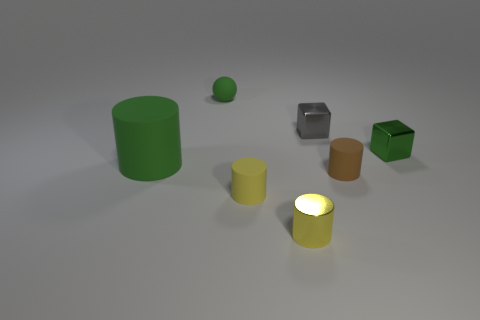What shapes are present in this image? The image features a variety of geometric shapes, including two cylinders (one large green and one small yellow), two cubes (one green and one metallic), a small green sphere, and a brown object that resembles a truncated cone or a very short cylinder. 